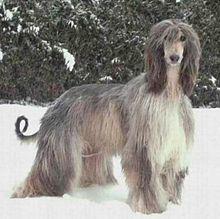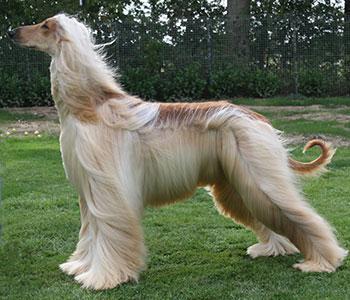The first image is the image on the left, the second image is the image on the right. Given the left and right images, does the statement "The right image has a dog standing on a grassy surface" hold true? Answer yes or no. Yes. The first image is the image on the left, the second image is the image on the right. For the images displayed, is the sentence "The dog in the left image is standing on snow-covered ground." factually correct? Answer yes or no. Yes. 